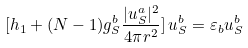Convert formula to latex. <formula><loc_0><loc_0><loc_500><loc_500>[ h _ { 1 } + ( N - 1 ) g _ { S } ^ { b } \frac { | u _ { S } ^ { a } | ^ { 2 } } { 4 \pi r ^ { 2 } } ] \, u _ { S } ^ { b } = \varepsilon _ { b } u _ { S } ^ { b }</formula> 